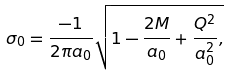Convert formula to latex. <formula><loc_0><loc_0><loc_500><loc_500>\sigma _ { 0 } = \frac { - 1 } { 2 \pi a _ { 0 } } \sqrt { 1 - \frac { 2 M } { a _ { 0 } } + \frac { Q ^ { 2 } } { a _ { 0 } ^ { 2 } } , }</formula> 